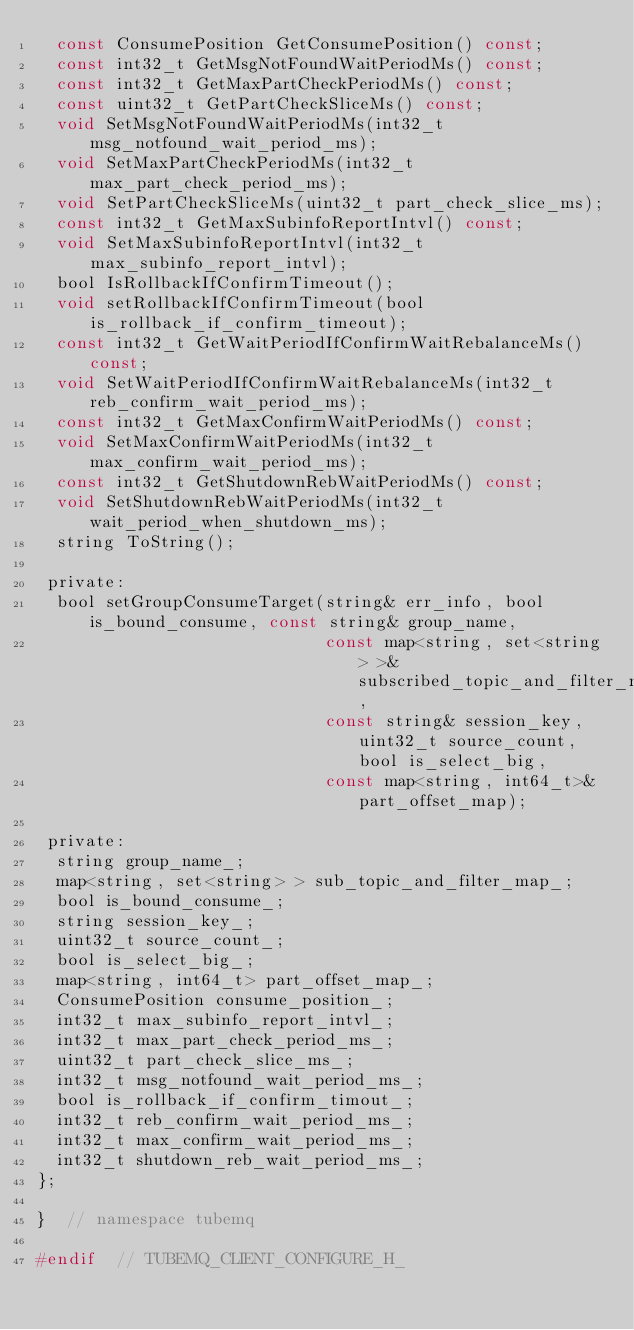Convert code to text. <code><loc_0><loc_0><loc_500><loc_500><_C_>  const ConsumePosition GetConsumePosition() const;
  const int32_t GetMsgNotFoundWaitPeriodMs() const;
  const int32_t GetMaxPartCheckPeriodMs() const;
  const uint32_t GetPartCheckSliceMs() const;
  void SetMsgNotFoundWaitPeriodMs(int32_t msg_notfound_wait_period_ms);
  void SetMaxPartCheckPeriodMs(int32_t max_part_check_period_ms);
  void SetPartCheckSliceMs(uint32_t part_check_slice_ms);
  const int32_t GetMaxSubinfoReportIntvl() const;
  void SetMaxSubinfoReportIntvl(int32_t max_subinfo_report_intvl);
  bool IsRollbackIfConfirmTimeout();
  void setRollbackIfConfirmTimeout(bool is_rollback_if_confirm_timeout);
  const int32_t GetWaitPeriodIfConfirmWaitRebalanceMs() const;
  void SetWaitPeriodIfConfirmWaitRebalanceMs(int32_t reb_confirm_wait_period_ms);
  const int32_t GetMaxConfirmWaitPeriodMs() const;
  void SetMaxConfirmWaitPeriodMs(int32_t max_confirm_wait_period_ms);
  const int32_t GetShutdownRebWaitPeriodMs() const;
  void SetShutdownRebWaitPeriodMs(int32_t wait_period_when_shutdown_ms);
  string ToString();

 private:
  bool setGroupConsumeTarget(string& err_info, bool is_bound_consume, const string& group_name,
                             const map<string, set<string> >& subscribed_topic_and_filter_map,
                             const string& session_key, uint32_t source_count, bool is_select_big,
                             const map<string, int64_t>& part_offset_map);

 private:
  string group_name_;
  map<string, set<string> > sub_topic_and_filter_map_;
  bool is_bound_consume_;
  string session_key_;
  uint32_t source_count_;
  bool is_select_big_;
  map<string, int64_t> part_offset_map_;
  ConsumePosition consume_position_;
  int32_t max_subinfo_report_intvl_;
  int32_t max_part_check_period_ms_;
  uint32_t part_check_slice_ms_;
  int32_t msg_notfound_wait_period_ms_;
  bool is_rollback_if_confirm_timout_;
  int32_t reb_confirm_wait_period_ms_;
  int32_t max_confirm_wait_period_ms_;
  int32_t shutdown_reb_wait_period_ms_;
};

}  // namespace tubemq

#endif  // TUBEMQ_CLIENT_CONFIGURE_H_
</code> 